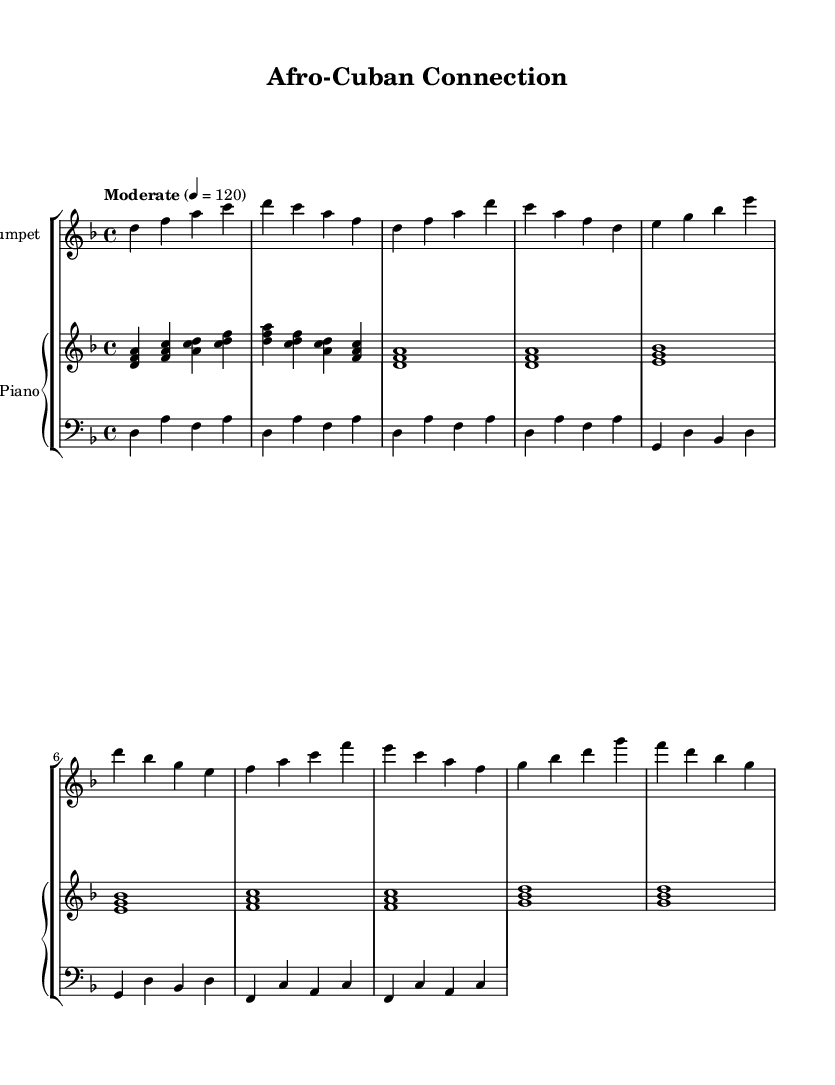What is the key signature of this music? The key signature is indicated by the presence of two flat symbols (B♭ and E♭). This identifies the piece as being in the key of D minor.
Answer: D minor What is the time signature of this music? The time signature is found at the beginning of the staff, represented as "4/4," meaning there are four beats in each measure and the quarter note gets one beat.
Answer: 4/4 What is the tempo marking of this music? The tempo marking appears above the staff with the indication "Moderate" followed by "4 = 120," meaning the quarter note should be played at a speed of 120 beats per minute.
Answer: Moderate 4 = 120 How many measures are in the trumpet part? By counting the number of vertical lines that separate the musical phrases in the trumpet part, we see there are a total of 8 measures.
Answer: 8 measures What is the first note of the piano part? The first note of the piano part is indicated at the beginning of the staff and is identified as D, which is part of the chord being played.
Answer: D Which instrument plays the bass part? The bass part is specifically notated in the score under a separate staff, indicated by the clef symbol at the beginning. It shows the part is played by the bass instrument.
Answer: Bass What type of music is "Afro-Cuban Connection"? This piece blends elements of jazz and Latin music, reflecting an Afro-Cuban influence in its rhythm and harmony.
Answer: Latin Jazz 